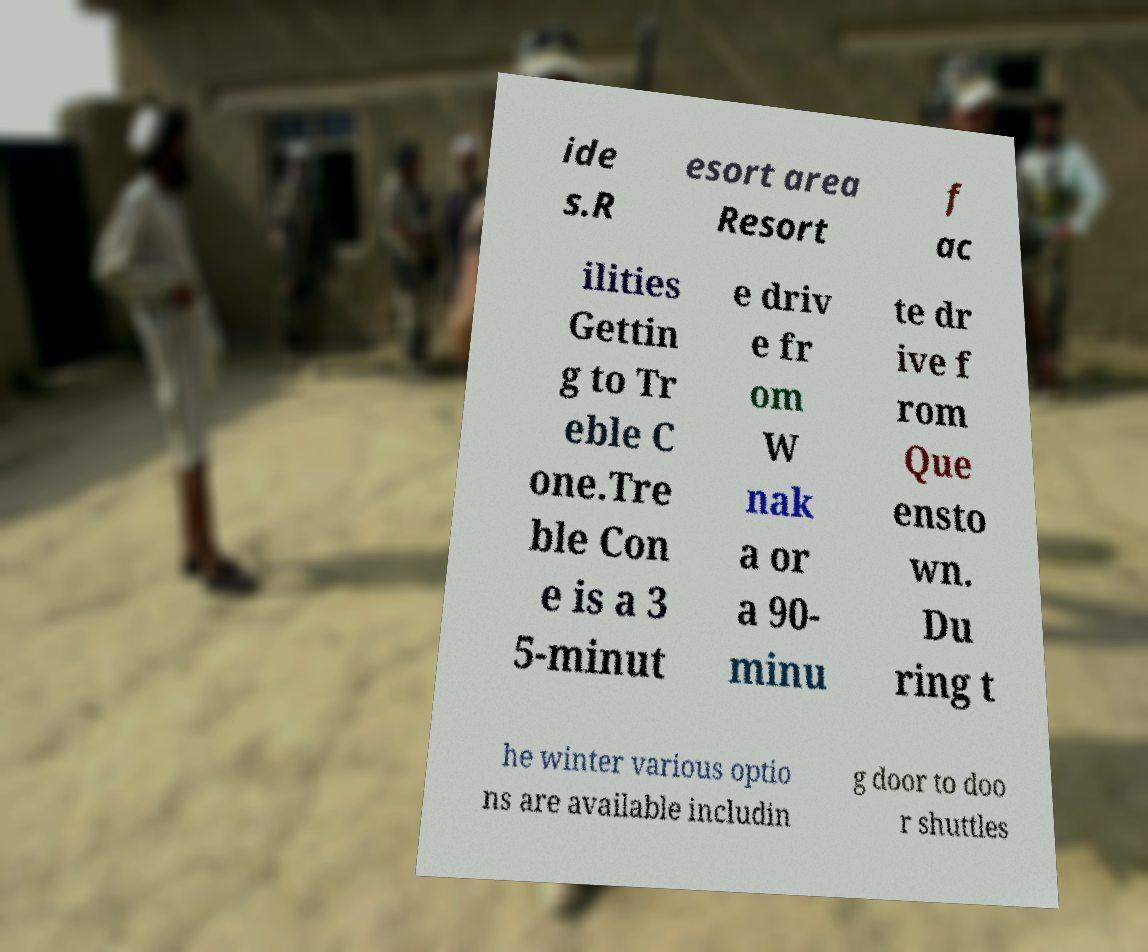Could you assist in decoding the text presented in this image and type it out clearly? ide s.R esort area Resort f ac ilities Gettin g to Tr eble C one.Tre ble Con e is a 3 5-minut e driv e fr om W nak a or a 90- minu te dr ive f rom Que ensto wn. Du ring t he winter various optio ns are available includin g door to doo r shuttles 